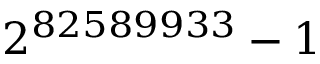Convert formula to latex. <formula><loc_0><loc_0><loc_500><loc_500>2 ^ { 8 2 5 8 9 9 3 3 } - 1</formula> 